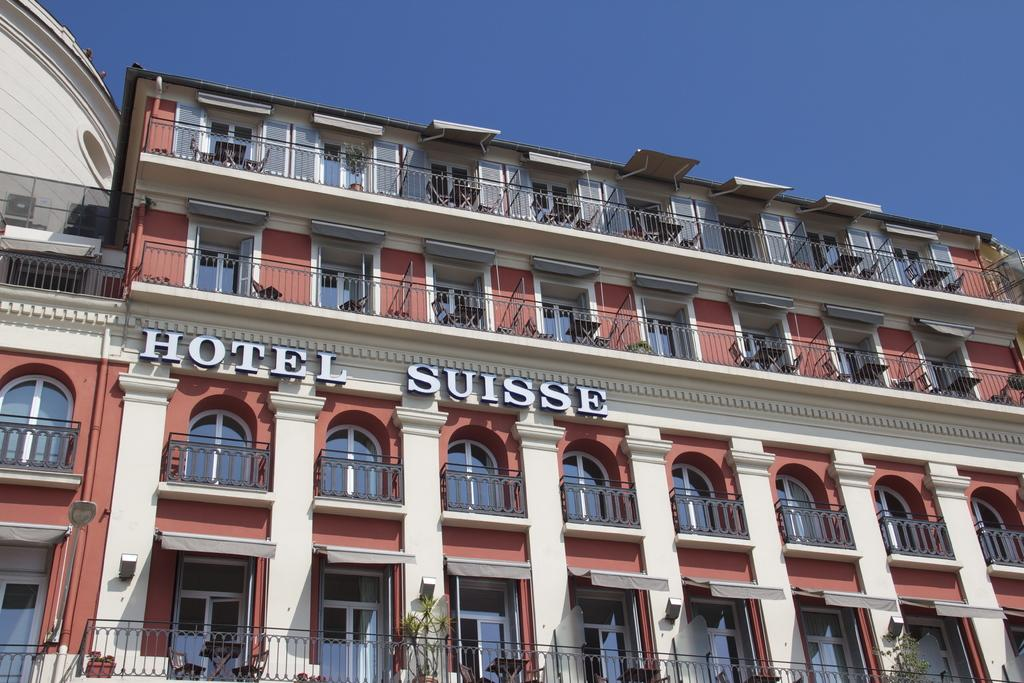What type of structure is depicted in the image? There is a building in the image. What are some of the features of the building? The building has walls, railings, glass windows, tables, chairs, plants, and pipes. Is there any text visible in the image? Yes, there is text on a wall in the image. What can be seen in the background of the image? The sky is visible at the top of the image. Can you see any oranges in the image? There are no oranges present in the image. 